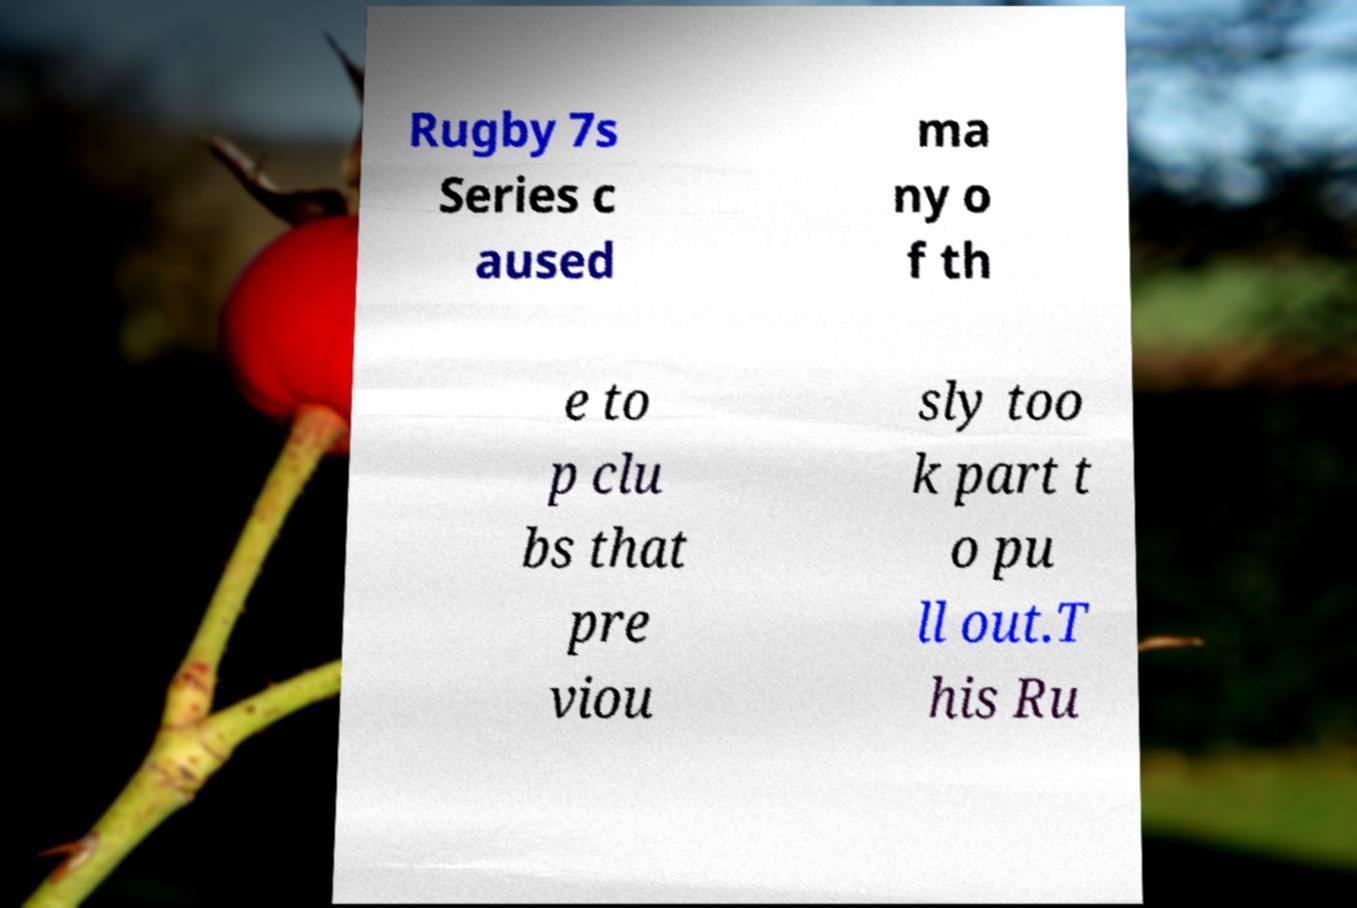I need the written content from this picture converted into text. Can you do that? Rugby 7s Series c aused ma ny o f th e to p clu bs that pre viou sly too k part t o pu ll out.T his Ru 